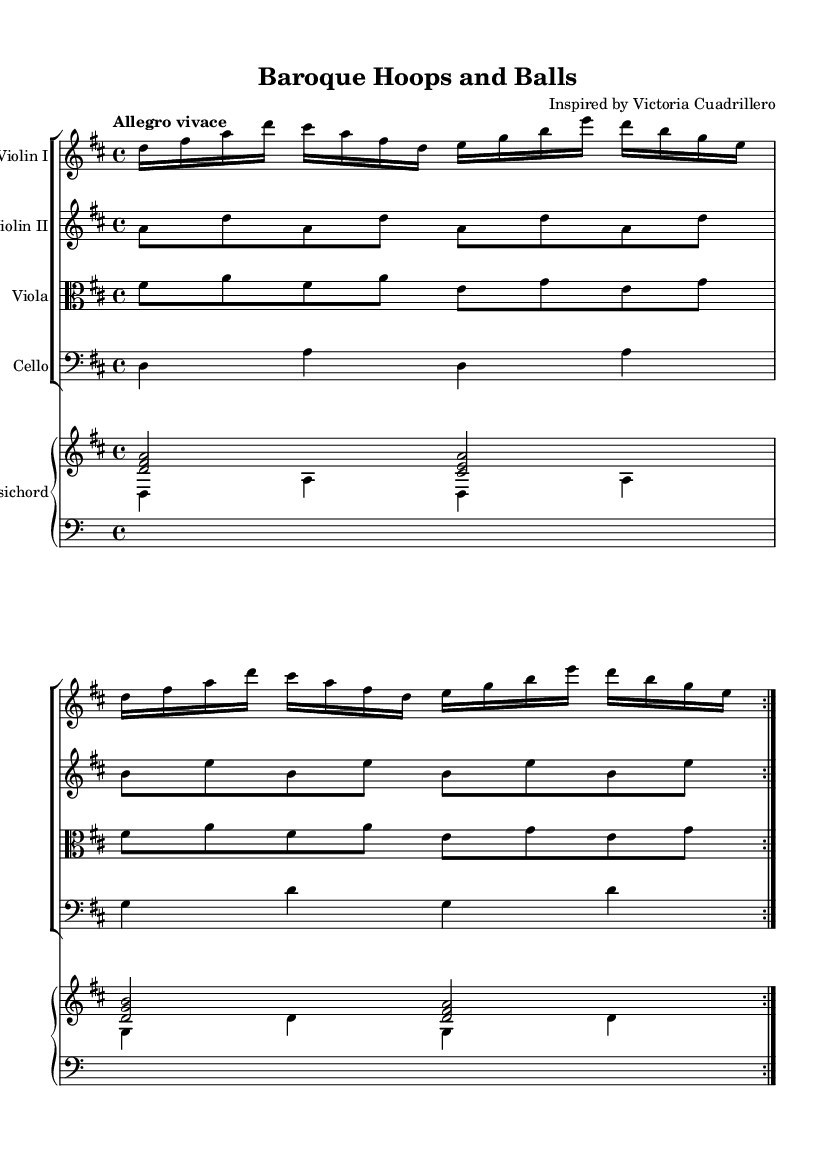What is the key signature of this music? The key signature is D major, which has two sharps (F# and C#). This can be identified by looking at the key signature at the beginning of the music.
Answer: D major What is the time signature of the piece? The time signature is 4/4, indicated directly after the key signature. This means there are four beats in each measure, and the quarter note gets the beat.
Answer: 4/4 What is the tempo marking for this composition? The tempo marking is "Allegro vivace", which suggests a fast and lively pace for the music. It is noted above the staff.
Answer: Allegro vivace How many repetitions are there for the main theme in Violin I? The main theme in Violin I is marked with a repeat sign and is played twice. This is seen by the repeat notation in the section.
Answer: 2 Which instruments are arranged in the score? The score contains Violin I, Violin II, Viola, Cello, and Harpsichord. These instruments are labeled at the beginning of each staff within the score.
Answer: Violin I, Violin II, Viola, Cello, Harpsichord What is the lowest instrument in this score? The lowest instrument in the score is the Cello, which is written in bass clef. The clef denotes lower pitches compared to the other instruments using treble clef.
Answer: Cello What is the structure of the accompaniment in the Harpsichord? The Harpsichord is structured with an upper and a lower voice; the upper voice plays chords, while the lower voice provides bass notes. This is indicated by the separate staves for each.
Answer: Upper and lower voice 